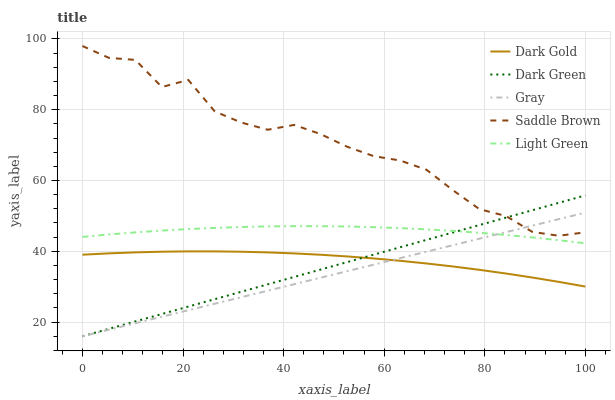Does Dark Green have the minimum area under the curve?
Answer yes or no. No. Does Dark Green have the maximum area under the curve?
Answer yes or no. No. Is Dark Green the smoothest?
Answer yes or no. No. Is Dark Green the roughest?
Answer yes or no. No. Does Saddle Brown have the lowest value?
Answer yes or no. No. Does Dark Green have the highest value?
Answer yes or no. No. Is Light Green less than Saddle Brown?
Answer yes or no. Yes. Is Saddle Brown greater than Light Green?
Answer yes or no. Yes. Does Light Green intersect Saddle Brown?
Answer yes or no. No. 